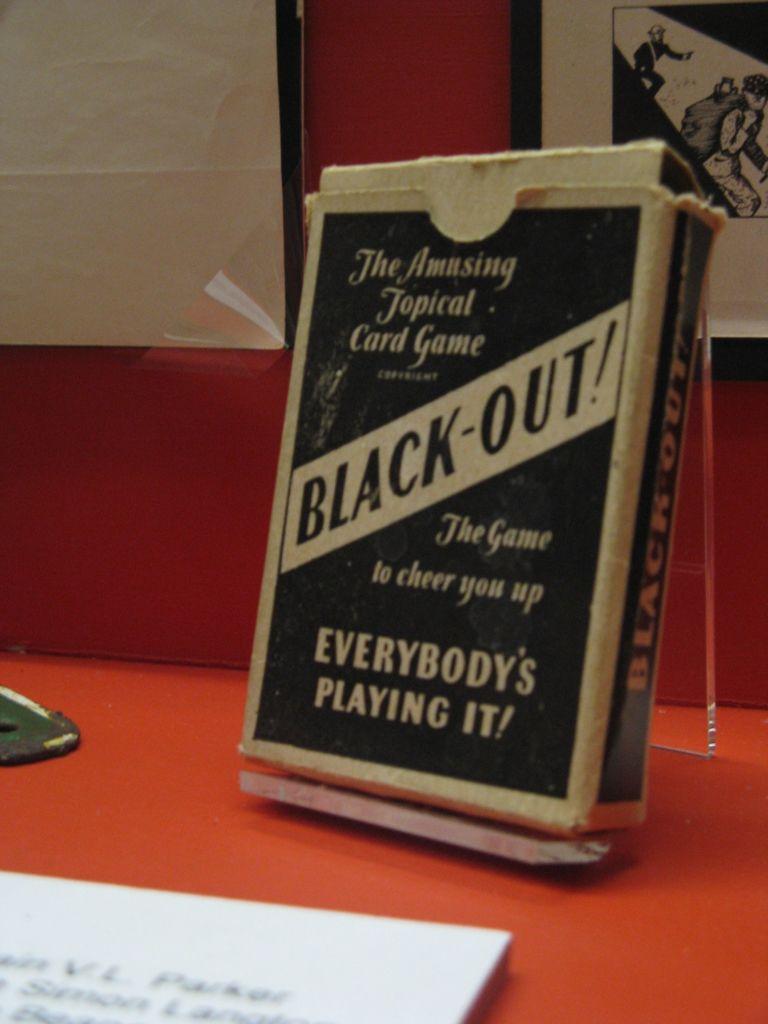What game is that?
Make the answer very short. Black-out!. What kind of game is this?
Ensure brevity in your answer.  Card game. 